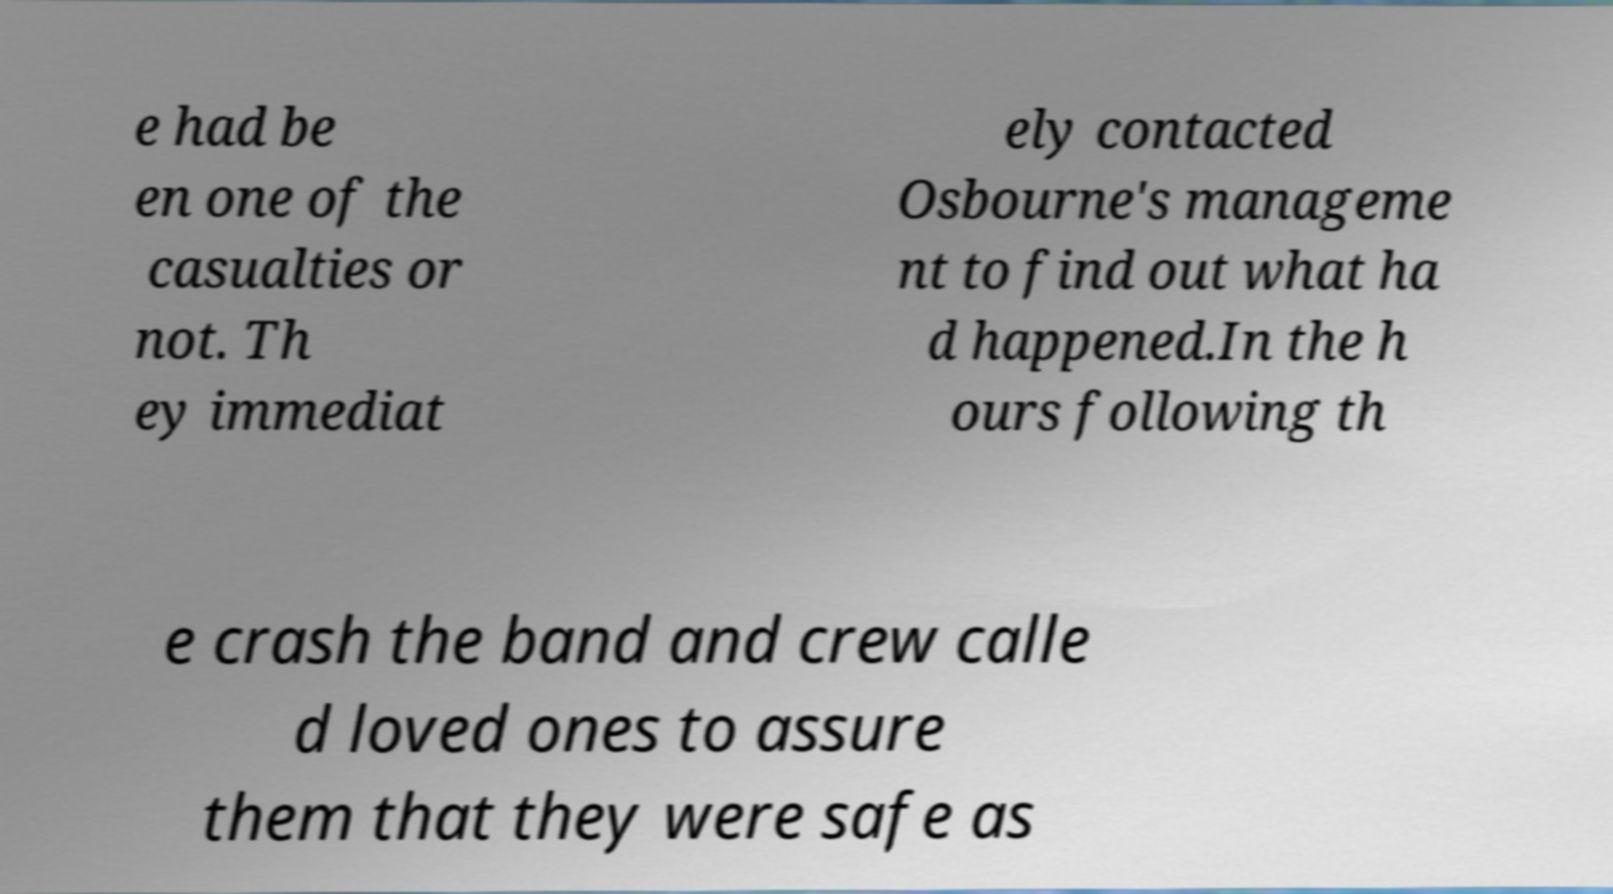I need the written content from this picture converted into text. Can you do that? e had be en one of the casualties or not. Th ey immediat ely contacted Osbourne's manageme nt to find out what ha d happened.In the h ours following th e crash the band and crew calle d loved ones to assure them that they were safe as 